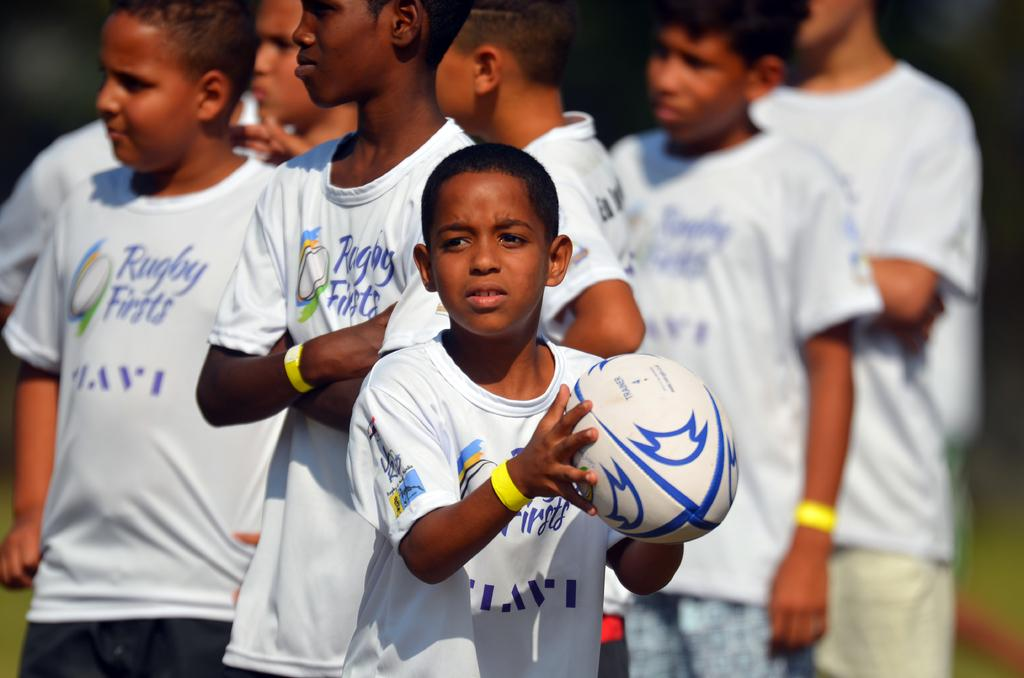Provide a one-sentence caption for the provided image. A group of kids wear shirts for a rugby team. 